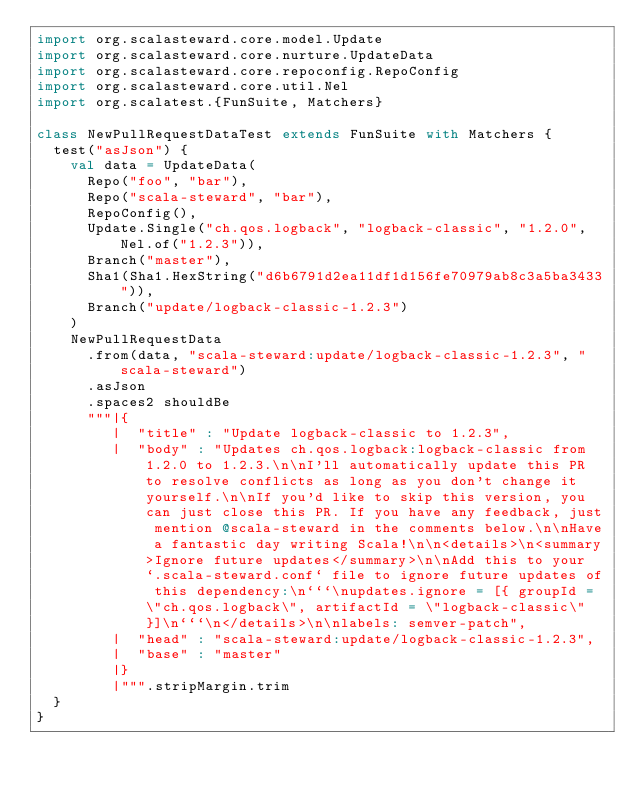Convert code to text. <code><loc_0><loc_0><loc_500><loc_500><_Scala_>import org.scalasteward.core.model.Update
import org.scalasteward.core.nurture.UpdateData
import org.scalasteward.core.repoconfig.RepoConfig
import org.scalasteward.core.util.Nel
import org.scalatest.{FunSuite, Matchers}

class NewPullRequestDataTest extends FunSuite with Matchers {
  test("asJson") {
    val data = UpdateData(
      Repo("foo", "bar"),
      Repo("scala-steward", "bar"),
      RepoConfig(),
      Update.Single("ch.qos.logback", "logback-classic", "1.2.0", Nel.of("1.2.3")),
      Branch("master"),
      Sha1(Sha1.HexString("d6b6791d2ea11df1d156fe70979ab8c3a5ba3433")),
      Branch("update/logback-classic-1.2.3")
    )
    NewPullRequestData
      .from(data, "scala-steward:update/logback-classic-1.2.3", "scala-steward")
      .asJson
      .spaces2 shouldBe
      """|{
         |  "title" : "Update logback-classic to 1.2.3",
         |  "body" : "Updates ch.qos.logback:logback-classic from 1.2.0 to 1.2.3.\n\nI'll automatically update this PR to resolve conflicts as long as you don't change it yourself.\n\nIf you'd like to skip this version, you can just close this PR. If you have any feedback, just mention @scala-steward in the comments below.\n\nHave a fantastic day writing Scala!\n\n<details>\n<summary>Ignore future updates</summary>\n\nAdd this to your `.scala-steward.conf` file to ignore future updates of this dependency:\n```\nupdates.ignore = [{ groupId = \"ch.qos.logback\", artifactId = \"logback-classic\" }]\n```\n</details>\n\nlabels: semver-patch",
         |  "head" : "scala-steward:update/logback-classic-1.2.3",
         |  "base" : "master"
         |}
         |""".stripMargin.trim
  }
}
</code> 